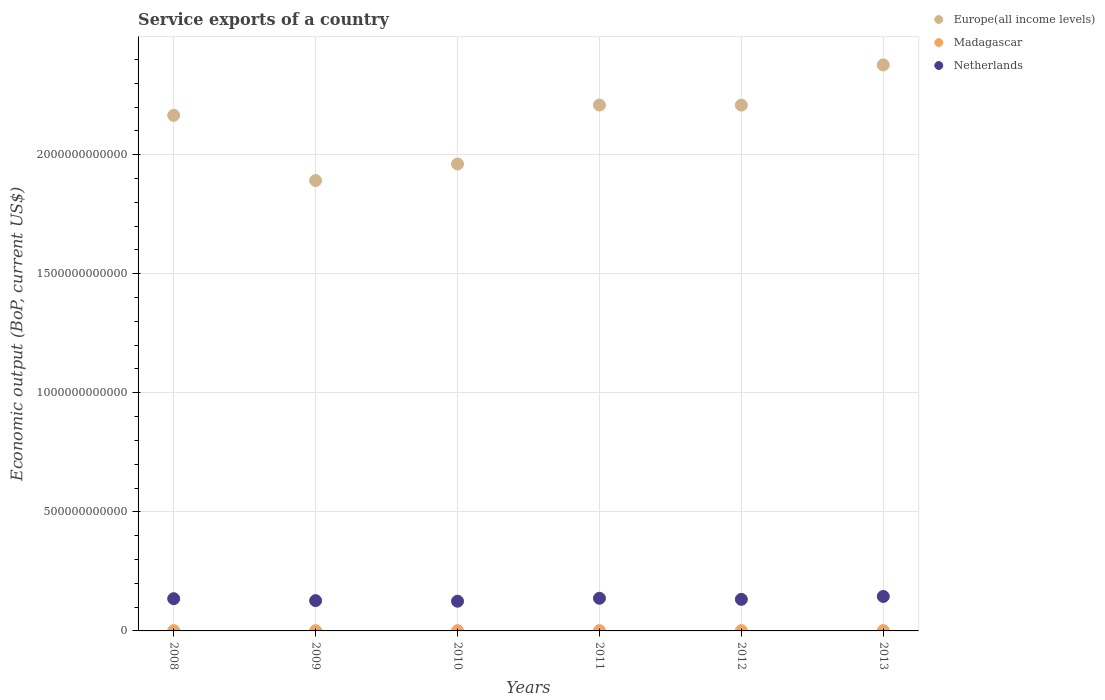How many different coloured dotlines are there?
Offer a terse response. 3. What is the service exports in Netherlands in 2008?
Keep it short and to the point. 1.35e+11. Across all years, what is the maximum service exports in Europe(all income levels)?
Give a very brief answer. 2.38e+12. Across all years, what is the minimum service exports in Netherlands?
Offer a very short reply. 1.25e+11. In which year was the service exports in Netherlands minimum?
Ensure brevity in your answer.  2010. What is the total service exports in Madagascar in the graph?
Provide a short and direct response. 6.92e+09. What is the difference between the service exports in Netherlands in 2008 and that in 2013?
Keep it short and to the point. -9.34e+09. What is the difference between the service exports in Madagascar in 2013 and the service exports in Europe(all income levels) in 2010?
Provide a succinct answer. -1.96e+12. What is the average service exports in Madagascar per year?
Ensure brevity in your answer.  1.15e+09. In the year 2008, what is the difference between the service exports in Madagascar and service exports in Europe(all income levels)?
Your answer should be very brief. -2.16e+12. What is the ratio of the service exports in Madagascar in 2011 to that in 2013?
Your response must be concise. 0.93. Is the service exports in Netherlands in 2011 less than that in 2013?
Your answer should be compact. Yes. What is the difference between the highest and the second highest service exports in Madagascar?
Provide a succinct answer. 1.82e+07. What is the difference between the highest and the lowest service exports in Netherlands?
Your answer should be very brief. 2.00e+1. Is it the case that in every year, the sum of the service exports in Netherlands and service exports in Madagascar  is greater than the service exports in Europe(all income levels)?
Your answer should be compact. No. Is the service exports in Netherlands strictly less than the service exports in Europe(all income levels) over the years?
Your answer should be very brief. Yes. How many dotlines are there?
Your answer should be compact. 3. How many years are there in the graph?
Keep it short and to the point. 6. What is the difference between two consecutive major ticks on the Y-axis?
Offer a very short reply. 5.00e+11. Are the values on the major ticks of Y-axis written in scientific E-notation?
Your answer should be very brief. No. Does the graph contain any zero values?
Provide a short and direct response. No. Does the graph contain grids?
Your response must be concise. Yes. How are the legend labels stacked?
Provide a succinct answer. Vertical. What is the title of the graph?
Offer a terse response. Service exports of a country. What is the label or title of the Y-axis?
Offer a very short reply. Economic output (BoP, current US$). What is the Economic output (BoP, current US$) of Europe(all income levels) in 2008?
Your answer should be compact. 2.17e+12. What is the Economic output (BoP, current US$) in Madagascar in 2008?
Offer a terse response. 1.30e+09. What is the Economic output (BoP, current US$) in Netherlands in 2008?
Keep it short and to the point. 1.35e+11. What is the Economic output (BoP, current US$) of Europe(all income levels) in 2009?
Ensure brevity in your answer.  1.89e+12. What is the Economic output (BoP, current US$) of Madagascar in 2009?
Offer a terse response. 8.60e+08. What is the Economic output (BoP, current US$) of Netherlands in 2009?
Keep it short and to the point. 1.27e+11. What is the Economic output (BoP, current US$) of Europe(all income levels) in 2010?
Provide a short and direct response. 1.96e+12. What is the Economic output (BoP, current US$) in Madagascar in 2010?
Your response must be concise. 1.01e+09. What is the Economic output (BoP, current US$) of Netherlands in 2010?
Make the answer very short. 1.25e+11. What is the Economic output (BoP, current US$) of Europe(all income levels) in 2011?
Ensure brevity in your answer.  2.21e+12. What is the Economic output (BoP, current US$) of Madagascar in 2011?
Keep it short and to the point. 1.17e+09. What is the Economic output (BoP, current US$) of Netherlands in 2011?
Ensure brevity in your answer.  1.37e+11. What is the Economic output (BoP, current US$) in Europe(all income levels) in 2012?
Your answer should be very brief. 2.21e+12. What is the Economic output (BoP, current US$) in Madagascar in 2012?
Your response must be concise. 1.31e+09. What is the Economic output (BoP, current US$) in Netherlands in 2012?
Your response must be concise. 1.33e+11. What is the Economic output (BoP, current US$) in Europe(all income levels) in 2013?
Keep it short and to the point. 2.38e+12. What is the Economic output (BoP, current US$) of Madagascar in 2013?
Your response must be concise. 1.26e+09. What is the Economic output (BoP, current US$) in Netherlands in 2013?
Offer a terse response. 1.45e+11. Across all years, what is the maximum Economic output (BoP, current US$) of Europe(all income levels)?
Offer a very short reply. 2.38e+12. Across all years, what is the maximum Economic output (BoP, current US$) in Madagascar?
Offer a very short reply. 1.31e+09. Across all years, what is the maximum Economic output (BoP, current US$) of Netherlands?
Your response must be concise. 1.45e+11. Across all years, what is the minimum Economic output (BoP, current US$) in Europe(all income levels)?
Provide a short and direct response. 1.89e+12. Across all years, what is the minimum Economic output (BoP, current US$) of Madagascar?
Your answer should be compact. 8.60e+08. Across all years, what is the minimum Economic output (BoP, current US$) of Netherlands?
Your answer should be compact. 1.25e+11. What is the total Economic output (BoP, current US$) of Europe(all income levels) in the graph?
Make the answer very short. 1.28e+13. What is the total Economic output (BoP, current US$) of Madagascar in the graph?
Provide a succinct answer. 6.92e+09. What is the total Economic output (BoP, current US$) of Netherlands in the graph?
Provide a succinct answer. 8.02e+11. What is the difference between the Economic output (BoP, current US$) of Europe(all income levels) in 2008 and that in 2009?
Make the answer very short. 2.74e+11. What is the difference between the Economic output (BoP, current US$) of Madagascar in 2008 and that in 2009?
Keep it short and to the point. 4.37e+08. What is the difference between the Economic output (BoP, current US$) of Netherlands in 2008 and that in 2009?
Your answer should be very brief. 8.22e+09. What is the difference between the Economic output (BoP, current US$) of Europe(all income levels) in 2008 and that in 2010?
Offer a very short reply. 2.04e+11. What is the difference between the Economic output (BoP, current US$) in Madagascar in 2008 and that in 2010?
Make the answer very short. 2.85e+08. What is the difference between the Economic output (BoP, current US$) of Netherlands in 2008 and that in 2010?
Your answer should be very brief. 1.07e+1. What is the difference between the Economic output (BoP, current US$) of Europe(all income levels) in 2008 and that in 2011?
Make the answer very short. -4.32e+1. What is the difference between the Economic output (BoP, current US$) in Madagascar in 2008 and that in 2011?
Provide a succinct answer. 1.23e+08. What is the difference between the Economic output (BoP, current US$) of Netherlands in 2008 and that in 2011?
Keep it short and to the point. -1.73e+09. What is the difference between the Economic output (BoP, current US$) of Europe(all income levels) in 2008 and that in 2012?
Make the answer very short. -4.28e+1. What is the difference between the Economic output (BoP, current US$) in Madagascar in 2008 and that in 2012?
Provide a succinct answer. -1.82e+07. What is the difference between the Economic output (BoP, current US$) in Netherlands in 2008 and that in 2012?
Offer a terse response. 2.80e+09. What is the difference between the Economic output (BoP, current US$) of Europe(all income levels) in 2008 and that in 2013?
Offer a terse response. -2.12e+11. What is the difference between the Economic output (BoP, current US$) in Madagascar in 2008 and that in 2013?
Make the answer very short. 3.18e+07. What is the difference between the Economic output (BoP, current US$) in Netherlands in 2008 and that in 2013?
Provide a succinct answer. -9.34e+09. What is the difference between the Economic output (BoP, current US$) in Europe(all income levels) in 2009 and that in 2010?
Give a very brief answer. -6.97e+1. What is the difference between the Economic output (BoP, current US$) in Madagascar in 2009 and that in 2010?
Your response must be concise. -1.52e+08. What is the difference between the Economic output (BoP, current US$) in Netherlands in 2009 and that in 2010?
Give a very brief answer. 2.43e+09. What is the difference between the Economic output (BoP, current US$) in Europe(all income levels) in 2009 and that in 2011?
Your answer should be very brief. -3.17e+11. What is the difference between the Economic output (BoP, current US$) in Madagascar in 2009 and that in 2011?
Provide a succinct answer. -3.13e+08. What is the difference between the Economic output (BoP, current US$) of Netherlands in 2009 and that in 2011?
Give a very brief answer. -9.95e+09. What is the difference between the Economic output (BoP, current US$) of Europe(all income levels) in 2009 and that in 2012?
Keep it short and to the point. -3.17e+11. What is the difference between the Economic output (BoP, current US$) in Madagascar in 2009 and that in 2012?
Give a very brief answer. -4.55e+08. What is the difference between the Economic output (BoP, current US$) of Netherlands in 2009 and that in 2012?
Provide a succinct answer. -5.42e+09. What is the difference between the Economic output (BoP, current US$) in Europe(all income levels) in 2009 and that in 2013?
Your answer should be compact. -4.86e+11. What is the difference between the Economic output (BoP, current US$) in Madagascar in 2009 and that in 2013?
Your answer should be compact. -4.05e+08. What is the difference between the Economic output (BoP, current US$) of Netherlands in 2009 and that in 2013?
Offer a terse response. -1.76e+1. What is the difference between the Economic output (BoP, current US$) of Europe(all income levels) in 2010 and that in 2011?
Your response must be concise. -2.48e+11. What is the difference between the Economic output (BoP, current US$) of Madagascar in 2010 and that in 2011?
Keep it short and to the point. -1.61e+08. What is the difference between the Economic output (BoP, current US$) of Netherlands in 2010 and that in 2011?
Offer a very short reply. -1.24e+1. What is the difference between the Economic output (BoP, current US$) in Europe(all income levels) in 2010 and that in 2012?
Give a very brief answer. -2.47e+11. What is the difference between the Economic output (BoP, current US$) of Madagascar in 2010 and that in 2012?
Make the answer very short. -3.03e+08. What is the difference between the Economic output (BoP, current US$) of Netherlands in 2010 and that in 2012?
Your answer should be very brief. -7.86e+09. What is the difference between the Economic output (BoP, current US$) in Europe(all income levels) in 2010 and that in 2013?
Ensure brevity in your answer.  -4.16e+11. What is the difference between the Economic output (BoP, current US$) in Madagascar in 2010 and that in 2013?
Give a very brief answer. -2.53e+08. What is the difference between the Economic output (BoP, current US$) in Netherlands in 2010 and that in 2013?
Your response must be concise. -2.00e+1. What is the difference between the Economic output (BoP, current US$) of Europe(all income levels) in 2011 and that in 2012?
Offer a terse response. 3.03e+08. What is the difference between the Economic output (BoP, current US$) of Madagascar in 2011 and that in 2012?
Your response must be concise. -1.41e+08. What is the difference between the Economic output (BoP, current US$) of Netherlands in 2011 and that in 2012?
Your answer should be very brief. 4.52e+09. What is the difference between the Economic output (BoP, current US$) in Europe(all income levels) in 2011 and that in 2013?
Your answer should be very brief. -1.69e+11. What is the difference between the Economic output (BoP, current US$) in Madagascar in 2011 and that in 2013?
Your answer should be compact. -9.16e+07. What is the difference between the Economic output (BoP, current US$) in Netherlands in 2011 and that in 2013?
Offer a terse response. -7.62e+09. What is the difference between the Economic output (BoP, current US$) of Europe(all income levels) in 2012 and that in 2013?
Ensure brevity in your answer.  -1.69e+11. What is the difference between the Economic output (BoP, current US$) of Madagascar in 2012 and that in 2013?
Your response must be concise. 4.99e+07. What is the difference between the Economic output (BoP, current US$) of Netherlands in 2012 and that in 2013?
Your response must be concise. -1.21e+1. What is the difference between the Economic output (BoP, current US$) in Europe(all income levels) in 2008 and the Economic output (BoP, current US$) in Madagascar in 2009?
Offer a terse response. 2.16e+12. What is the difference between the Economic output (BoP, current US$) of Europe(all income levels) in 2008 and the Economic output (BoP, current US$) of Netherlands in 2009?
Your answer should be compact. 2.04e+12. What is the difference between the Economic output (BoP, current US$) of Madagascar in 2008 and the Economic output (BoP, current US$) of Netherlands in 2009?
Keep it short and to the point. -1.26e+11. What is the difference between the Economic output (BoP, current US$) of Europe(all income levels) in 2008 and the Economic output (BoP, current US$) of Madagascar in 2010?
Your response must be concise. 2.16e+12. What is the difference between the Economic output (BoP, current US$) in Europe(all income levels) in 2008 and the Economic output (BoP, current US$) in Netherlands in 2010?
Give a very brief answer. 2.04e+12. What is the difference between the Economic output (BoP, current US$) in Madagascar in 2008 and the Economic output (BoP, current US$) in Netherlands in 2010?
Your answer should be compact. -1.23e+11. What is the difference between the Economic output (BoP, current US$) in Europe(all income levels) in 2008 and the Economic output (BoP, current US$) in Madagascar in 2011?
Ensure brevity in your answer.  2.16e+12. What is the difference between the Economic output (BoP, current US$) in Europe(all income levels) in 2008 and the Economic output (BoP, current US$) in Netherlands in 2011?
Ensure brevity in your answer.  2.03e+12. What is the difference between the Economic output (BoP, current US$) of Madagascar in 2008 and the Economic output (BoP, current US$) of Netherlands in 2011?
Your answer should be compact. -1.36e+11. What is the difference between the Economic output (BoP, current US$) of Europe(all income levels) in 2008 and the Economic output (BoP, current US$) of Madagascar in 2012?
Give a very brief answer. 2.16e+12. What is the difference between the Economic output (BoP, current US$) of Europe(all income levels) in 2008 and the Economic output (BoP, current US$) of Netherlands in 2012?
Your answer should be compact. 2.03e+12. What is the difference between the Economic output (BoP, current US$) in Madagascar in 2008 and the Economic output (BoP, current US$) in Netherlands in 2012?
Offer a very short reply. -1.31e+11. What is the difference between the Economic output (BoP, current US$) of Europe(all income levels) in 2008 and the Economic output (BoP, current US$) of Madagascar in 2013?
Your answer should be compact. 2.16e+12. What is the difference between the Economic output (BoP, current US$) of Europe(all income levels) in 2008 and the Economic output (BoP, current US$) of Netherlands in 2013?
Offer a terse response. 2.02e+12. What is the difference between the Economic output (BoP, current US$) of Madagascar in 2008 and the Economic output (BoP, current US$) of Netherlands in 2013?
Your answer should be compact. -1.43e+11. What is the difference between the Economic output (BoP, current US$) in Europe(all income levels) in 2009 and the Economic output (BoP, current US$) in Madagascar in 2010?
Your answer should be very brief. 1.89e+12. What is the difference between the Economic output (BoP, current US$) in Europe(all income levels) in 2009 and the Economic output (BoP, current US$) in Netherlands in 2010?
Provide a short and direct response. 1.77e+12. What is the difference between the Economic output (BoP, current US$) of Madagascar in 2009 and the Economic output (BoP, current US$) of Netherlands in 2010?
Ensure brevity in your answer.  -1.24e+11. What is the difference between the Economic output (BoP, current US$) in Europe(all income levels) in 2009 and the Economic output (BoP, current US$) in Madagascar in 2011?
Provide a short and direct response. 1.89e+12. What is the difference between the Economic output (BoP, current US$) of Europe(all income levels) in 2009 and the Economic output (BoP, current US$) of Netherlands in 2011?
Provide a short and direct response. 1.75e+12. What is the difference between the Economic output (BoP, current US$) in Madagascar in 2009 and the Economic output (BoP, current US$) in Netherlands in 2011?
Keep it short and to the point. -1.36e+11. What is the difference between the Economic output (BoP, current US$) of Europe(all income levels) in 2009 and the Economic output (BoP, current US$) of Madagascar in 2012?
Give a very brief answer. 1.89e+12. What is the difference between the Economic output (BoP, current US$) in Europe(all income levels) in 2009 and the Economic output (BoP, current US$) in Netherlands in 2012?
Offer a terse response. 1.76e+12. What is the difference between the Economic output (BoP, current US$) of Madagascar in 2009 and the Economic output (BoP, current US$) of Netherlands in 2012?
Ensure brevity in your answer.  -1.32e+11. What is the difference between the Economic output (BoP, current US$) of Europe(all income levels) in 2009 and the Economic output (BoP, current US$) of Madagascar in 2013?
Your answer should be very brief. 1.89e+12. What is the difference between the Economic output (BoP, current US$) of Europe(all income levels) in 2009 and the Economic output (BoP, current US$) of Netherlands in 2013?
Offer a very short reply. 1.75e+12. What is the difference between the Economic output (BoP, current US$) in Madagascar in 2009 and the Economic output (BoP, current US$) in Netherlands in 2013?
Offer a very short reply. -1.44e+11. What is the difference between the Economic output (BoP, current US$) of Europe(all income levels) in 2010 and the Economic output (BoP, current US$) of Madagascar in 2011?
Provide a short and direct response. 1.96e+12. What is the difference between the Economic output (BoP, current US$) in Europe(all income levels) in 2010 and the Economic output (BoP, current US$) in Netherlands in 2011?
Offer a terse response. 1.82e+12. What is the difference between the Economic output (BoP, current US$) in Madagascar in 2010 and the Economic output (BoP, current US$) in Netherlands in 2011?
Offer a terse response. -1.36e+11. What is the difference between the Economic output (BoP, current US$) in Europe(all income levels) in 2010 and the Economic output (BoP, current US$) in Madagascar in 2012?
Give a very brief answer. 1.96e+12. What is the difference between the Economic output (BoP, current US$) in Europe(all income levels) in 2010 and the Economic output (BoP, current US$) in Netherlands in 2012?
Your answer should be compact. 1.83e+12. What is the difference between the Economic output (BoP, current US$) in Madagascar in 2010 and the Economic output (BoP, current US$) in Netherlands in 2012?
Offer a very short reply. -1.32e+11. What is the difference between the Economic output (BoP, current US$) in Europe(all income levels) in 2010 and the Economic output (BoP, current US$) in Madagascar in 2013?
Give a very brief answer. 1.96e+12. What is the difference between the Economic output (BoP, current US$) in Europe(all income levels) in 2010 and the Economic output (BoP, current US$) in Netherlands in 2013?
Your answer should be very brief. 1.82e+12. What is the difference between the Economic output (BoP, current US$) of Madagascar in 2010 and the Economic output (BoP, current US$) of Netherlands in 2013?
Give a very brief answer. -1.44e+11. What is the difference between the Economic output (BoP, current US$) in Europe(all income levels) in 2011 and the Economic output (BoP, current US$) in Madagascar in 2012?
Offer a very short reply. 2.21e+12. What is the difference between the Economic output (BoP, current US$) of Europe(all income levels) in 2011 and the Economic output (BoP, current US$) of Netherlands in 2012?
Give a very brief answer. 2.08e+12. What is the difference between the Economic output (BoP, current US$) in Madagascar in 2011 and the Economic output (BoP, current US$) in Netherlands in 2012?
Provide a short and direct response. -1.31e+11. What is the difference between the Economic output (BoP, current US$) of Europe(all income levels) in 2011 and the Economic output (BoP, current US$) of Madagascar in 2013?
Provide a short and direct response. 2.21e+12. What is the difference between the Economic output (BoP, current US$) in Europe(all income levels) in 2011 and the Economic output (BoP, current US$) in Netherlands in 2013?
Your answer should be very brief. 2.06e+12. What is the difference between the Economic output (BoP, current US$) in Madagascar in 2011 and the Economic output (BoP, current US$) in Netherlands in 2013?
Your response must be concise. -1.44e+11. What is the difference between the Economic output (BoP, current US$) of Europe(all income levels) in 2012 and the Economic output (BoP, current US$) of Madagascar in 2013?
Offer a very short reply. 2.21e+12. What is the difference between the Economic output (BoP, current US$) of Europe(all income levels) in 2012 and the Economic output (BoP, current US$) of Netherlands in 2013?
Provide a short and direct response. 2.06e+12. What is the difference between the Economic output (BoP, current US$) of Madagascar in 2012 and the Economic output (BoP, current US$) of Netherlands in 2013?
Offer a very short reply. -1.43e+11. What is the average Economic output (BoP, current US$) in Europe(all income levels) per year?
Offer a very short reply. 2.14e+12. What is the average Economic output (BoP, current US$) in Madagascar per year?
Your response must be concise. 1.15e+09. What is the average Economic output (BoP, current US$) of Netherlands per year?
Offer a very short reply. 1.34e+11. In the year 2008, what is the difference between the Economic output (BoP, current US$) of Europe(all income levels) and Economic output (BoP, current US$) of Madagascar?
Make the answer very short. 2.16e+12. In the year 2008, what is the difference between the Economic output (BoP, current US$) of Europe(all income levels) and Economic output (BoP, current US$) of Netherlands?
Make the answer very short. 2.03e+12. In the year 2008, what is the difference between the Economic output (BoP, current US$) of Madagascar and Economic output (BoP, current US$) of Netherlands?
Offer a very short reply. -1.34e+11. In the year 2009, what is the difference between the Economic output (BoP, current US$) of Europe(all income levels) and Economic output (BoP, current US$) of Madagascar?
Make the answer very short. 1.89e+12. In the year 2009, what is the difference between the Economic output (BoP, current US$) in Europe(all income levels) and Economic output (BoP, current US$) in Netherlands?
Provide a succinct answer. 1.76e+12. In the year 2009, what is the difference between the Economic output (BoP, current US$) of Madagascar and Economic output (BoP, current US$) of Netherlands?
Make the answer very short. -1.26e+11. In the year 2010, what is the difference between the Economic output (BoP, current US$) in Europe(all income levels) and Economic output (BoP, current US$) in Madagascar?
Your answer should be compact. 1.96e+12. In the year 2010, what is the difference between the Economic output (BoP, current US$) of Europe(all income levels) and Economic output (BoP, current US$) of Netherlands?
Provide a short and direct response. 1.84e+12. In the year 2010, what is the difference between the Economic output (BoP, current US$) of Madagascar and Economic output (BoP, current US$) of Netherlands?
Your response must be concise. -1.24e+11. In the year 2011, what is the difference between the Economic output (BoP, current US$) of Europe(all income levels) and Economic output (BoP, current US$) of Madagascar?
Offer a very short reply. 2.21e+12. In the year 2011, what is the difference between the Economic output (BoP, current US$) in Europe(all income levels) and Economic output (BoP, current US$) in Netherlands?
Provide a short and direct response. 2.07e+12. In the year 2011, what is the difference between the Economic output (BoP, current US$) of Madagascar and Economic output (BoP, current US$) of Netherlands?
Give a very brief answer. -1.36e+11. In the year 2012, what is the difference between the Economic output (BoP, current US$) of Europe(all income levels) and Economic output (BoP, current US$) of Madagascar?
Provide a short and direct response. 2.21e+12. In the year 2012, what is the difference between the Economic output (BoP, current US$) of Europe(all income levels) and Economic output (BoP, current US$) of Netherlands?
Offer a terse response. 2.08e+12. In the year 2012, what is the difference between the Economic output (BoP, current US$) of Madagascar and Economic output (BoP, current US$) of Netherlands?
Offer a very short reply. -1.31e+11. In the year 2013, what is the difference between the Economic output (BoP, current US$) in Europe(all income levels) and Economic output (BoP, current US$) in Madagascar?
Provide a succinct answer. 2.38e+12. In the year 2013, what is the difference between the Economic output (BoP, current US$) in Europe(all income levels) and Economic output (BoP, current US$) in Netherlands?
Keep it short and to the point. 2.23e+12. In the year 2013, what is the difference between the Economic output (BoP, current US$) in Madagascar and Economic output (BoP, current US$) in Netherlands?
Offer a very short reply. -1.43e+11. What is the ratio of the Economic output (BoP, current US$) in Europe(all income levels) in 2008 to that in 2009?
Provide a succinct answer. 1.14. What is the ratio of the Economic output (BoP, current US$) of Madagascar in 2008 to that in 2009?
Make the answer very short. 1.51. What is the ratio of the Economic output (BoP, current US$) of Netherlands in 2008 to that in 2009?
Ensure brevity in your answer.  1.06. What is the ratio of the Economic output (BoP, current US$) of Europe(all income levels) in 2008 to that in 2010?
Give a very brief answer. 1.1. What is the ratio of the Economic output (BoP, current US$) of Madagascar in 2008 to that in 2010?
Ensure brevity in your answer.  1.28. What is the ratio of the Economic output (BoP, current US$) in Netherlands in 2008 to that in 2010?
Offer a terse response. 1.09. What is the ratio of the Economic output (BoP, current US$) in Europe(all income levels) in 2008 to that in 2011?
Offer a very short reply. 0.98. What is the ratio of the Economic output (BoP, current US$) of Madagascar in 2008 to that in 2011?
Give a very brief answer. 1.11. What is the ratio of the Economic output (BoP, current US$) of Netherlands in 2008 to that in 2011?
Your response must be concise. 0.99. What is the ratio of the Economic output (BoP, current US$) in Europe(all income levels) in 2008 to that in 2012?
Keep it short and to the point. 0.98. What is the ratio of the Economic output (BoP, current US$) of Madagascar in 2008 to that in 2012?
Make the answer very short. 0.99. What is the ratio of the Economic output (BoP, current US$) of Netherlands in 2008 to that in 2012?
Ensure brevity in your answer.  1.02. What is the ratio of the Economic output (BoP, current US$) of Europe(all income levels) in 2008 to that in 2013?
Keep it short and to the point. 0.91. What is the ratio of the Economic output (BoP, current US$) in Madagascar in 2008 to that in 2013?
Offer a very short reply. 1.03. What is the ratio of the Economic output (BoP, current US$) in Netherlands in 2008 to that in 2013?
Ensure brevity in your answer.  0.94. What is the ratio of the Economic output (BoP, current US$) of Europe(all income levels) in 2009 to that in 2010?
Offer a terse response. 0.96. What is the ratio of the Economic output (BoP, current US$) in Madagascar in 2009 to that in 2010?
Give a very brief answer. 0.85. What is the ratio of the Economic output (BoP, current US$) in Netherlands in 2009 to that in 2010?
Give a very brief answer. 1.02. What is the ratio of the Economic output (BoP, current US$) in Europe(all income levels) in 2009 to that in 2011?
Provide a short and direct response. 0.86. What is the ratio of the Economic output (BoP, current US$) of Madagascar in 2009 to that in 2011?
Keep it short and to the point. 0.73. What is the ratio of the Economic output (BoP, current US$) in Netherlands in 2009 to that in 2011?
Make the answer very short. 0.93. What is the ratio of the Economic output (BoP, current US$) in Europe(all income levels) in 2009 to that in 2012?
Give a very brief answer. 0.86. What is the ratio of the Economic output (BoP, current US$) in Madagascar in 2009 to that in 2012?
Keep it short and to the point. 0.65. What is the ratio of the Economic output (BoP, current US$) in Netherlands in 2009 to that in 2012?
Make the answer very short. 0.96. What is the ratio of the Economic output (BoP, current US$) in Europe(all income levels) in 2009 to that in 2013?
Offer a very short reply. 0.8. What is the ratio of the Economic output (BoP, current US$) of Madagascar in 2009 to that in 2013?
Make the answer very short. 0.68. What is the ratio of the Economic output (BoP, current US$) in Netherlands in 2009 to that in 2013?
Offer a very short reply. 0.88. What is the ratio of the Economic output (BoP, current US$) in Europe(all income levels) in 2010 to that in 2011?
Give a very brief answer. 0.89. What is the ratio of the Economic output (BoP, current US$) of Madagascar in 2010 to that in 2011?
Your response must be concise. 0.86. What is the ratio of the Economic output (BoP, current US$) in Netherlands in 2010 to that in 2011?
Make the answer very short. 0.91. What is the ratio of the Economic output (BoP, current US$) of Europe(all income levels) in 2010 to that in 2012?
Your response must be concise. 0.89. What is the ratio of the Economic output (BoP, current US$) in Madagascar in 2010 to that in 2012?
Ensure brevity in your answer.  0.77. What is the ratio of the Economic output (BoP, current US$) of Netherlands in 2010 to that in 2012?
Ensure brevity in your answer.  0.94. What is the ratio of the Economic output (BoP, current US$) in Europe(all income levels) in 2010 to that in 2013?
Provide a succinct answer. 0.82. What is the ratio of the Economic output (BoP, current US$) of Madagascar in 2010 to that in 2013?
Provide a short and direct response. 0.8. What is the ratio of the Economic output (BoP, current US$) in Netherlands in 2010 to that in 2013?
Make the answer very short. 0.86. What is the ratio of the Economic output (BoP, current US$) in Europe(all income levels) in 2011 to that in 2012?
Give a very brief answer. 1. What is the ratio of the Economic output (BoP, current US$) of Madagascar in 2011 to that in 2012?
Keep it short and to the point. 0.89. What is the ratio of the Economic output (BoP, current US$) in Netherlands in 2011 to that in 2012?
Provide a short and direct response. 1.03. What is the ratio of the Economic output (BoP, current US$) in Europe(all income levels) in 2011 to that in 2013?
Give a very brief answer. 0.93. What is the ratio of the Economic output (BoP, current US$) in Madagascar in 2011 to that in 2013?
Give a very brief answer. 0.93. What is the ratio of the Economic output (BoP, current US$) of Europe(all income levels) in 2012 to that in 2013?
Your answer should be compact. 0.93. What is the ratio of the Economic output (BoP, current US$) in Madagascar in 2012 to that in 2013?
Keep it short and to the point. 1.04. What is the ratio of the Economic output (BoP, current US$) of Netherlands in 2012 to that in 2013?
Offer a terse response. 0.92. What is the difference between the highest and the second highest Economic output (BoP, current US$) of Europe(all income levels)?
Keep it short and to the point. 1.69e+11. What is the difference between the highest and the second highest Economic output (BoP, current US$) in Madagascar?
Provide a short and direct response. 1.82e+07. What is the difference between the highest and the second highest Economic output (BoP, current US$) in Netherlands?
Keep it short and to the point. 7.62e+09. What is the difference between the highest and the lowest Economic output (BoP, current US$) in Europe(all income levels)?
Provide a short and direct response. 4.86e+11. What is the difference between the highest and the lowest Economic output (BoP, current US$) in Madagascar?
Offer a terse response. 4.55e+08. What is the difference between the highest and the lowest Economic output (BoP, current US$) in Netherlands?
Keep it short and to the point. 2.00e+1. 